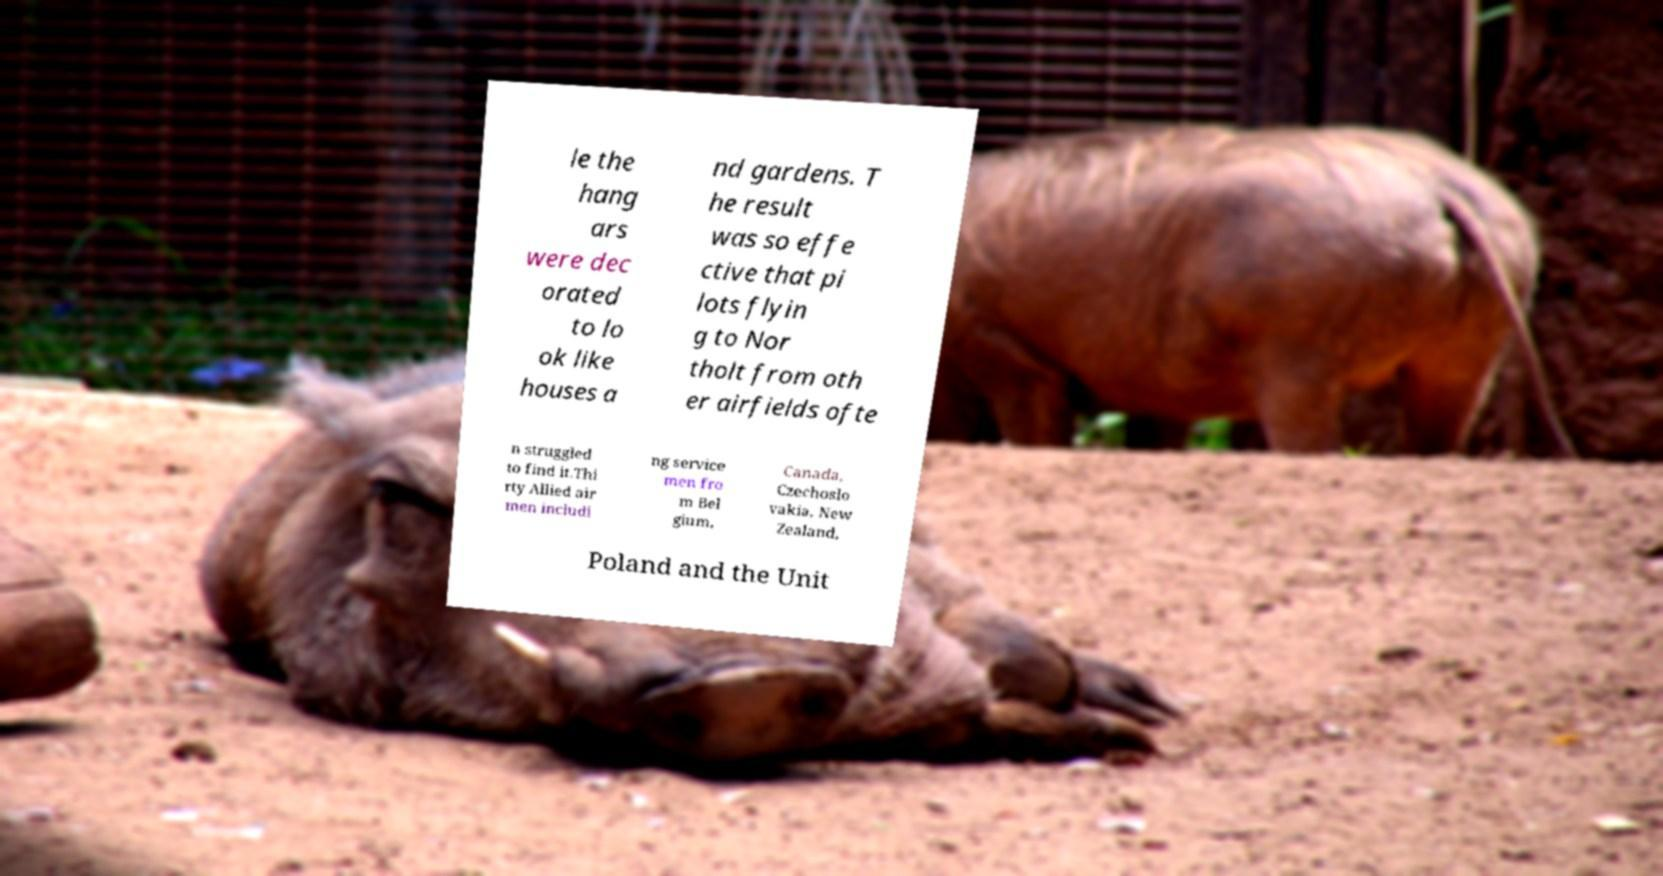There's text embedded in this image that I need extracted. Can you transcribe it verbatim? le the hang ars were dec orated to lo ok like houses a nd gardens. T he result was so effe ctive that pi lots flyin g to Nor tholt from oth er airfields ofte n struggled to find it.Thi rty Allied air men includi ng service men fro m Bel gium, Canada, Czechoslo vakia, New Zealand, Poland and the Unit 